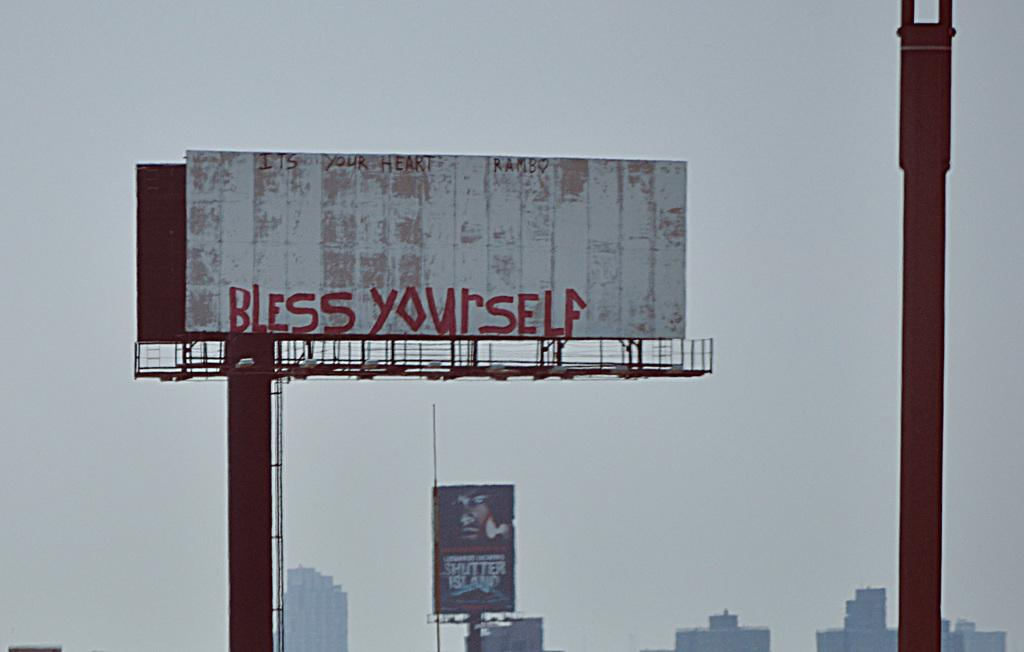<image>
Create a compact narrative representing the image presented. A billboard displaying graffiti that says "Bless Yourself". 